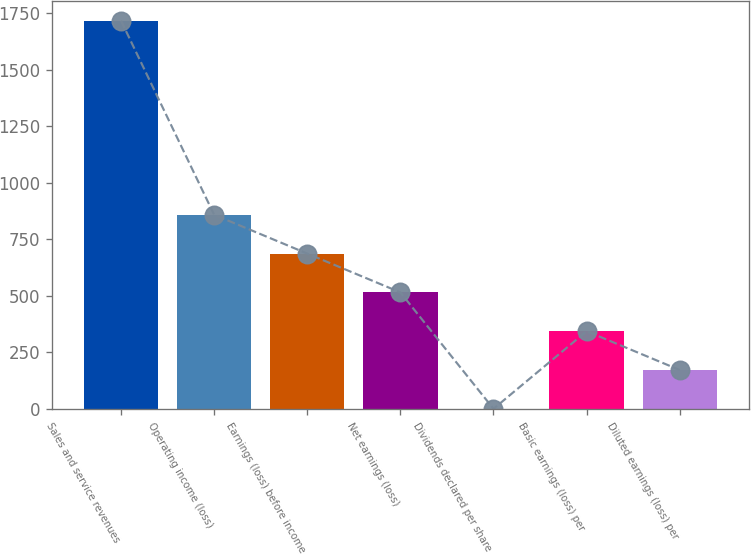Convert chart. <chart><loc_0><loc_0><loc_500><loc_500><bar_chart><fcel>Sales and service revenues<fcel>Operating income (loss)<fcel>Earnings (loss) before income<fcel>Net earnings (loss)<fcel>Dividends declared per share<fcel>Basic earnings (loss) per<fcel>Diluted earnings (loss) per<nl><fcel>1717<fcel>858.6<fcel>686.92<fcel>515.24<fcel>0.2<fcel>343.56<fcel>171.88<nl></chart> 